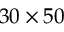Convert formula to latex. <formula><loc_0><loc_0><loc_500><loc_500>3 0 \times 5 0</formula> 